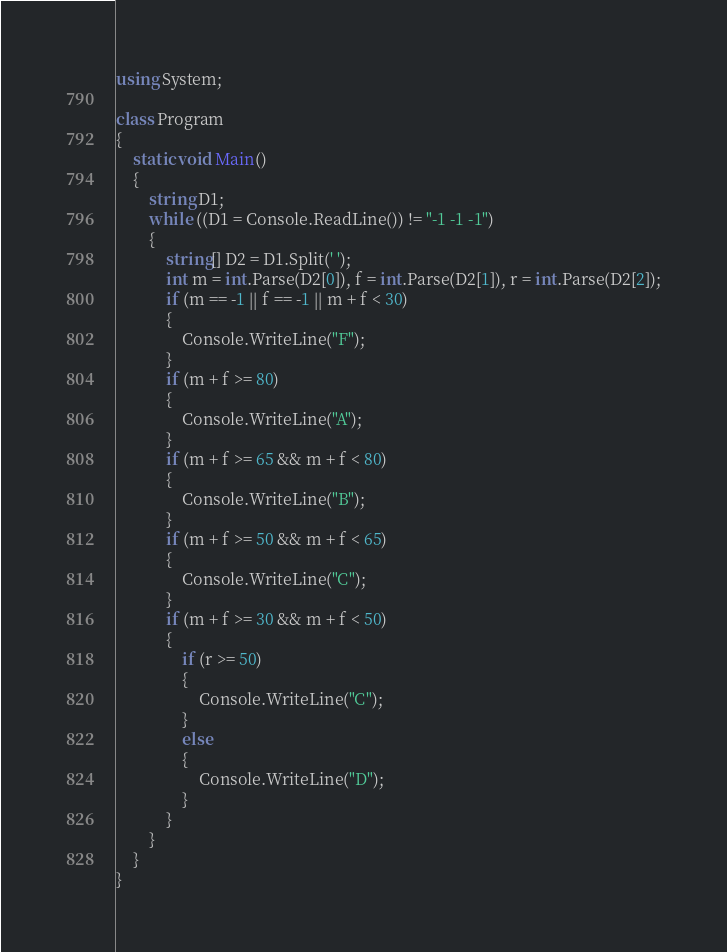Convert code to text. <code><loc_0><loc_0><loc_500><loc_500><_C#_>using System;

class Program
{
	static void Main()
	{
		string D1;
		while ((D1 = Console.ReadLine()) != "-1 -1 -1")
		{
			string[] D2 = D1.Split(' ');
			int m = int.Parse(D2[0]), f = int.Parse(D2[1]), r = int.Parse(D2[2]);
			if (m == -1 || f == -1 || m + f < 30)
			{
				Console.WriteLine("F");
			}
			if (m + f >= 80)
			{
				Console.WriteLine("A");
			}
			if (m + f >= 65 && m + f < 80)
			{
				Console.WriteLine("B");
			}
			if (m + f >= 50 && m + f < 65)
			{
				Console.WriteLine("C");
			}
			if (m + f >= 30 && m + f < 50)
			{
				if (r >= 50)
				{
					Console.WriteLine("C");
				}
				else
				{
					Console.WriteLine("D");
				}
			}
		}
	}
}</code> 